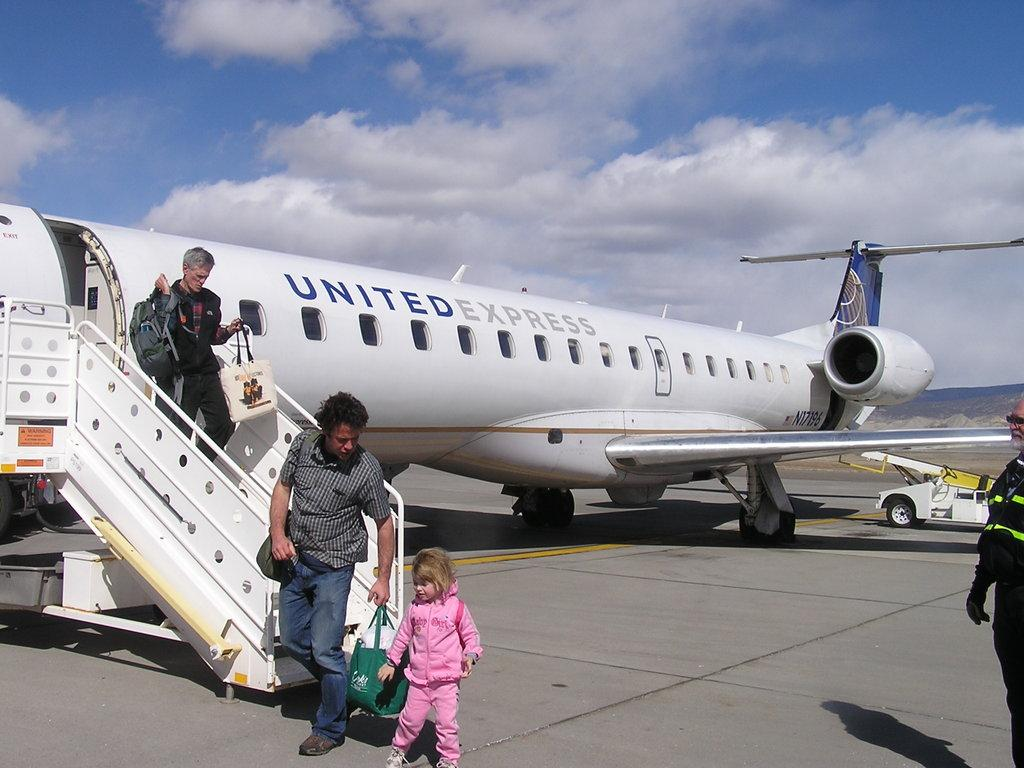Provide a one-sentence caption for the provided image. a N17196 UNITED EXPRESS plane where people are leaving from. 